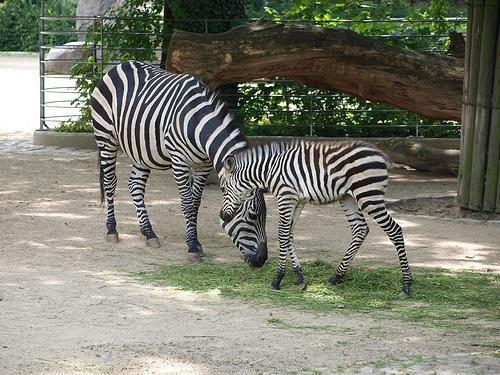How many rungs on the metal fence are above the zebras?
Give a very brief answer. 3. 